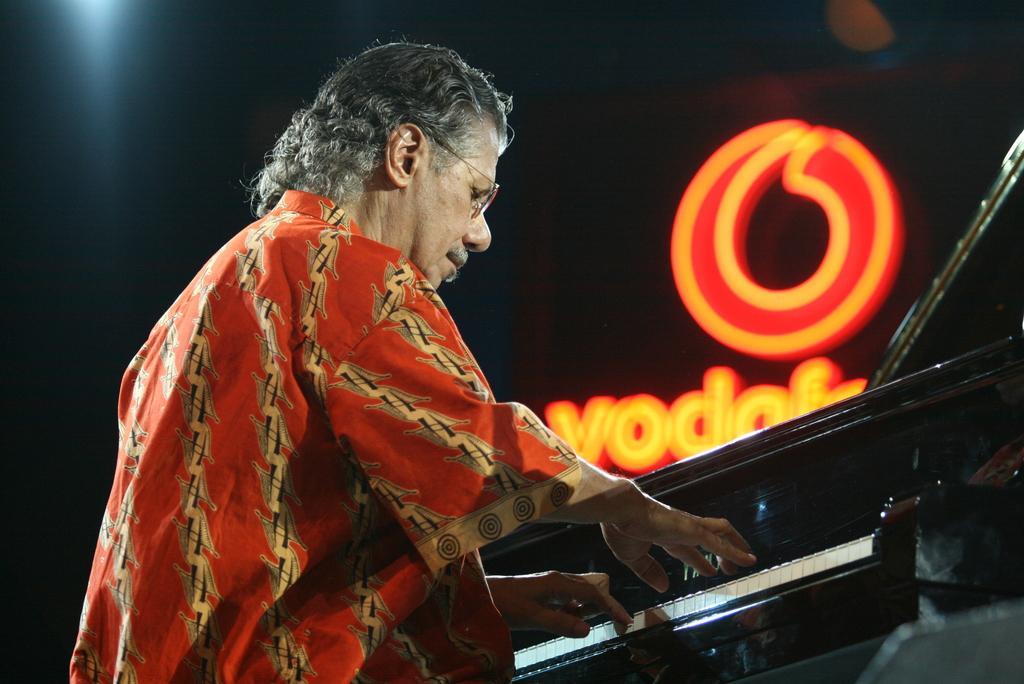How would you summarize this image in a sentence or two? This man wore spectacles and red dress and playing this piano keyboard. On top there is a logo in red and orange color. 